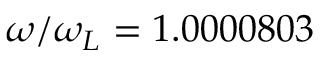<formula> <loc_0><loc_0><loc_500><loc_500>\omega / \omega _ { L } = 1 . 0 0 0 0 8 0 3</formula> 